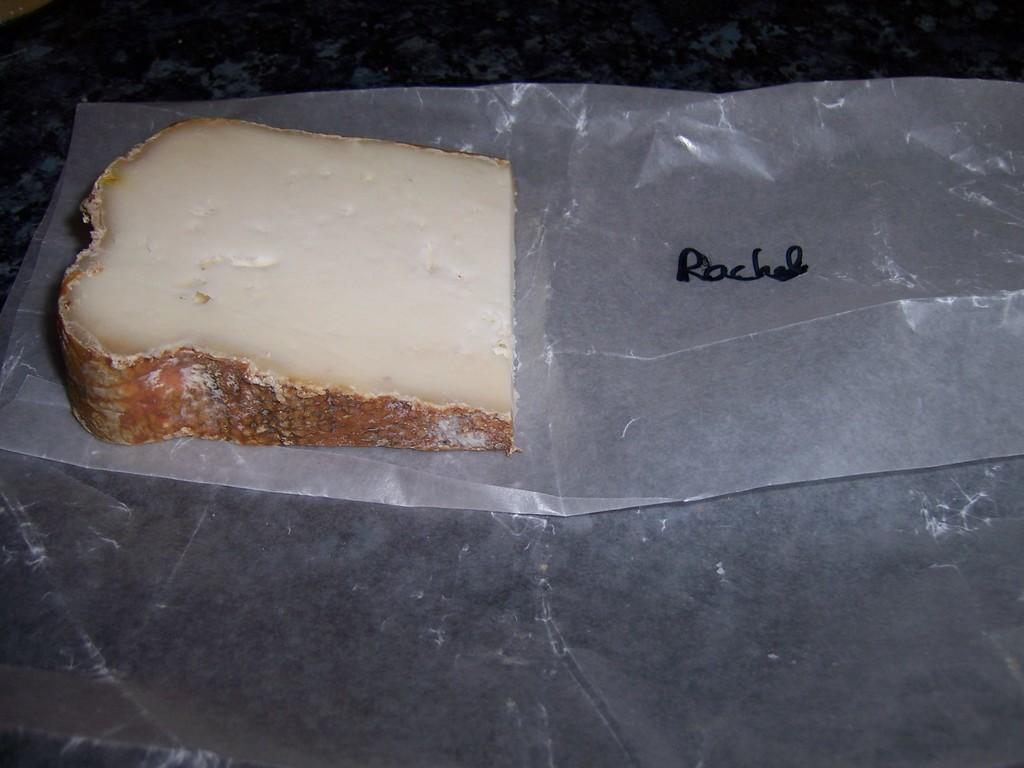Can you describe this image briefly? In this image I can see a cheese slices and a cover on the table. This image is taken in a room. 